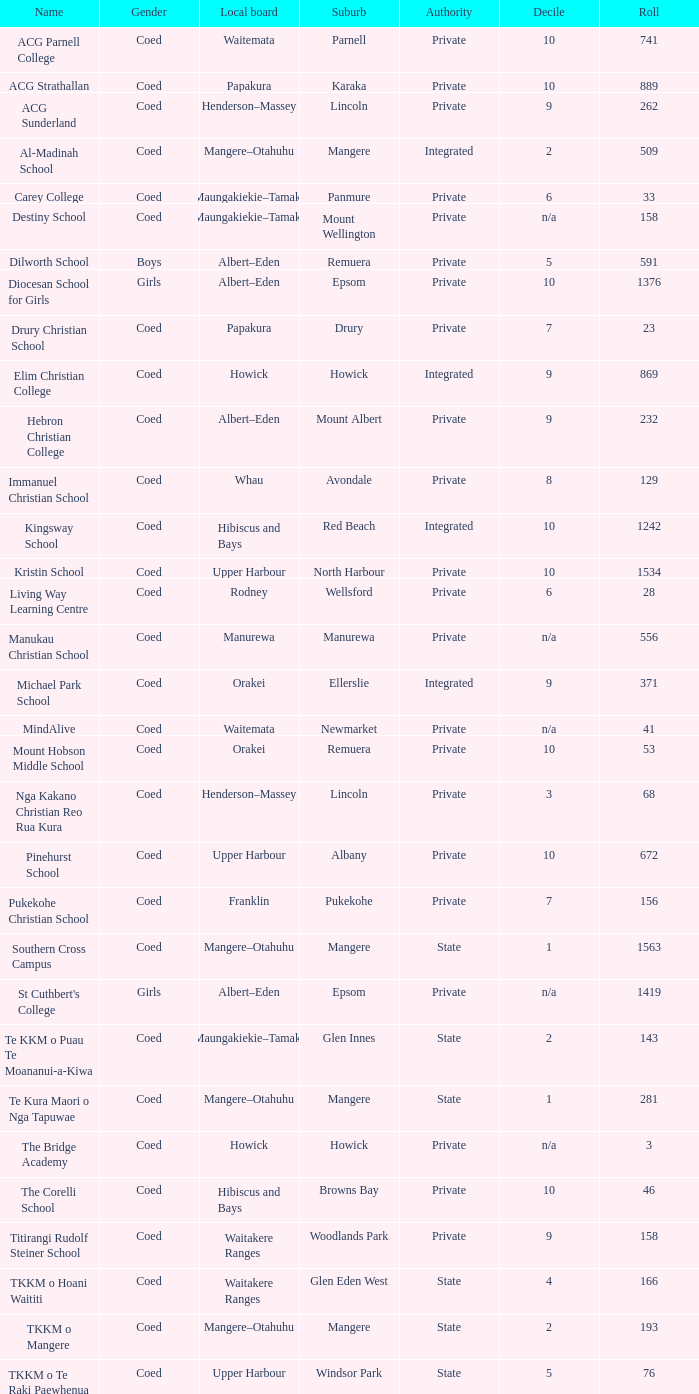What is the name of the suburb with a roll of 741? Parnell. Could you help me parse every detail presented in this table? {'header': ['Name', 'Gender', 'Local board', 'Suburb', 'Authority', 'Decile', 'Roll'], 'rows': [['ACG Parnell College', 'Coed', 'Waitemata', 'Parnell', 'Private', '10', '741'], ['ACG Strathallan', 'Coed', 'Papakura', 'Karaka', 'Private', '10', '889'], ['ACG Sunderland', 'Coed', 'Henderson–Massey', 'Lincoln', 'Private', '9', '262'], ['Al-Madinah School', 'Coed', 'Mangere–Otahuhu', 'Mangere', 'Integrated', '2', '509'], ['Carey College', 'Coed', 'Maungakiekie–Tamaki', 'Panmure', 'Private', '6', '33'], ['Destiny School', 'Coed', 'Maungakiekie–Tamaki', 'Mount Wellington', 'Private', 'n/a', '158'], ['Dilworth School', 'Boys', 'Albert–Eden', 'Remuera', 'Private', '5', '591'], ['Diocesan School for Girls', 'Girls', 'Albert–Eden', 'Epsom', 'Private', '10', '1376'], ['Drury Christian School', 'Coed', 'Papakura', 'Drury', 'Private', '7', '23'], ['Elim Christian College', 'Coed', 'Howick', 'Howick', 'Integrated', '9', '869'], ['Hebron Christian College', 'Coed', 'Albert–Eden', 'Mount Albert', 'Private', '9', '232'], ['Immanuel Christian School', 'Coed', 'Whau', 'Avondale', 'Private', '8', '129'], ['Kingsway School', 'Coed', 'Hibiscus and Bays', 'Red Beach', 'Integrated', '10', '1242'], ['Kristin School', 'Coed', 'Upper Harbour', 'North Harbour', 'Private', '10', '1534'], ['Living Way Learning Centre', 'Coed', 'Rodney', 'Wellsford', 'Private', '6', '28'], ['Manukau Christian School', 'Coed', 'Manurewa', 'Manurewa', 'Private', 'n/a', '556'], ['Michael Park School', 'Coed', 'Orakei', 'Ellerslie', 'Integrated', '9', '371'], ['MindAlive', 'Coed', 'Waitemata', 'Newmarket', 'Private', 'n/a', '41'], ['Mount Hobson Middle School', 'Coed', 'Orakei', 'Remuera', 'Private', '10', '53'], ['Nga Kakano Christian Reo Rua Kura', 'Coed', 'Henderson–Massey', 'Lincoln', 'Private', '3', '68'], ['Pinehurst School', 'Coed', 'Upper Harbour', 'Albany', 'Private', '10', '672'], ['Pukekohe Christian School', 'Coed', 'Franklin', 'Pukekohe', 'Private', '7', '156'], ['Southern Cross Campus', 'Coed', 'Mangere–Otahuhu', 'Mangere', 'State', '1', '1563'], ["St Cuthbert's College", 'Girls', 'Albert–Eden', 'Epsom', 'Private', 'n/a', '1419'], ['Te KKM o Puau Te Moananui-a-Kiwa', 'Coed', 'Maungakiekie–Tamaki', 'Glen Innes', 'State', '2', '143'], ['Te Kura Maori o Nga Tapuwae', 'Coed', 'Mangere–Otahuhu', 'Mangere', 'State', '1', '281'], ['The Bridge Academy', 'Coed', 'Howick', 'Howick', 'Private', 'n/a', '3'], ['The Corelli School', 'Coed', 'Hibiscus and Bays', 'Browns Bay', 'Private', '10', '46'], ['Titirangi Rudolf Steiner School', 'Coed', 'Waitakere Ranges', 'Woodlands Park', 'Private', '9', '158'], ['TKKM o Hoani Waititi', 'Coed', 'Waitakere Ranges', 'Glen Eden West', 'State', '4', '166'], ['TKKM o Mangere', 'Coed', 'Mangere–Otahuhu', 'Mangere', 'State', '2', '193'], ['TKKM o Te Raki Paewhenua', 'Coed', 'Upper Harbour', 'Windsor Park', 'State', '5', '76'], ['Tyndale Park Christian School', 'Coed', 'Howick', 'Flat Bush', 'Private', 'n/a', '120']]} 